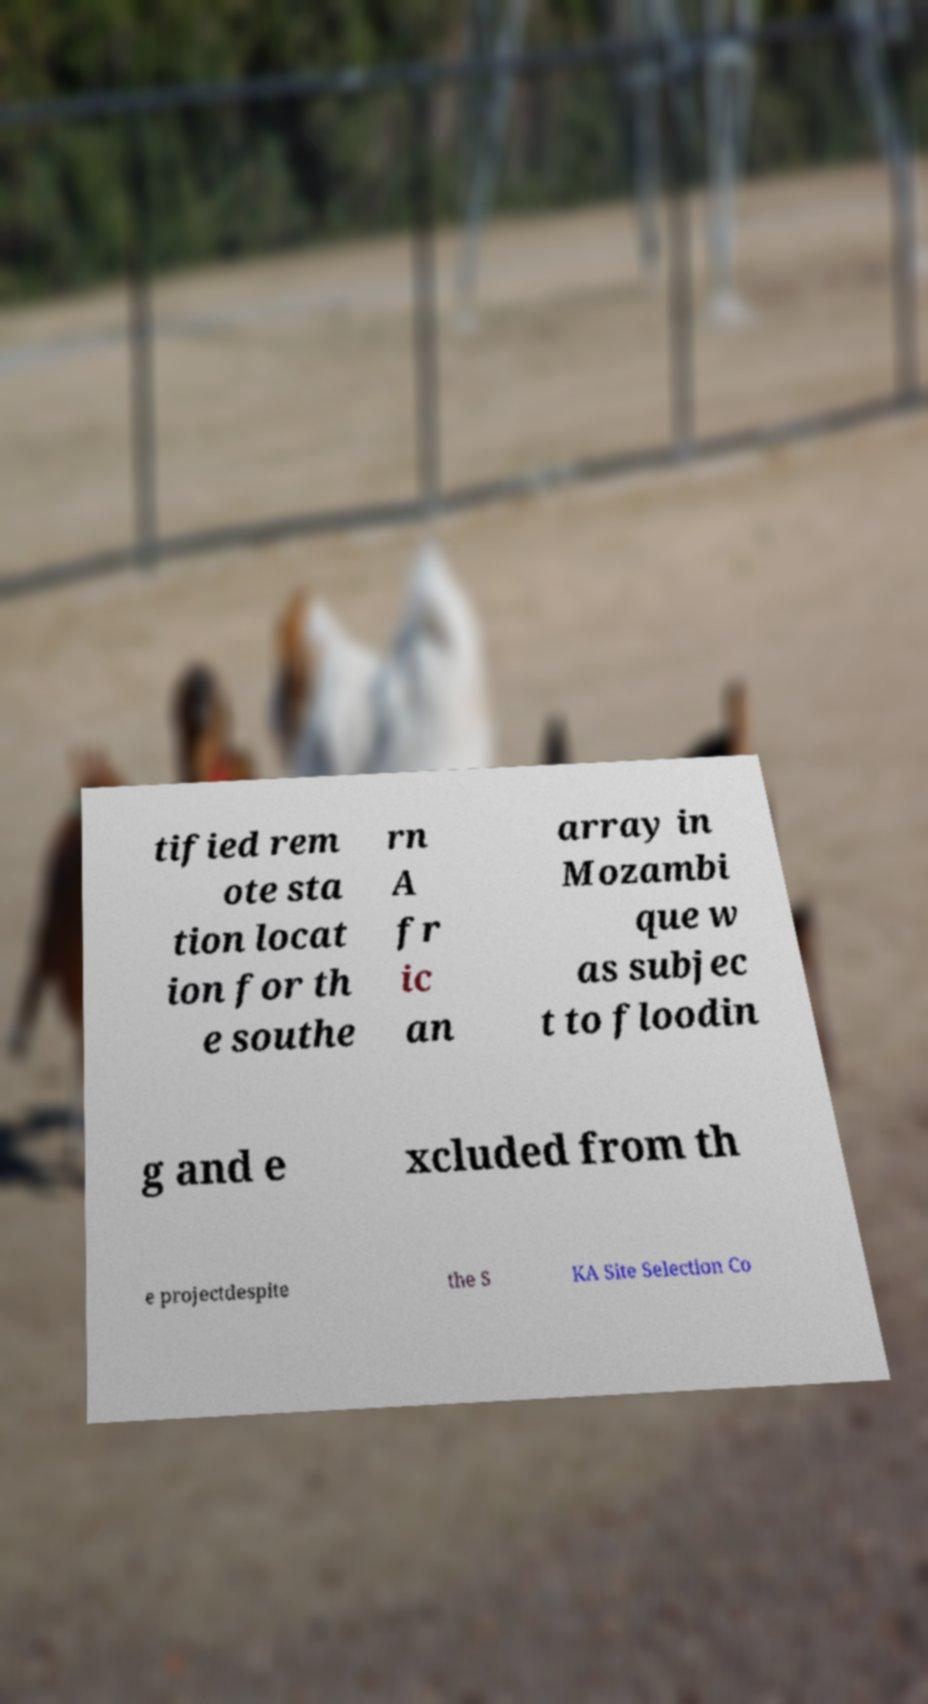Can you read and provide the text displayed in the image?This photo seems to have some interesting text. Can you extract and type it out for me? tified rem ote sta tion locat ion for th e southe rn A fr ic an array in Mozambi que w as subjec t to floodin g and e xcluded from th e projectdespite the S KA Site Selection Co 